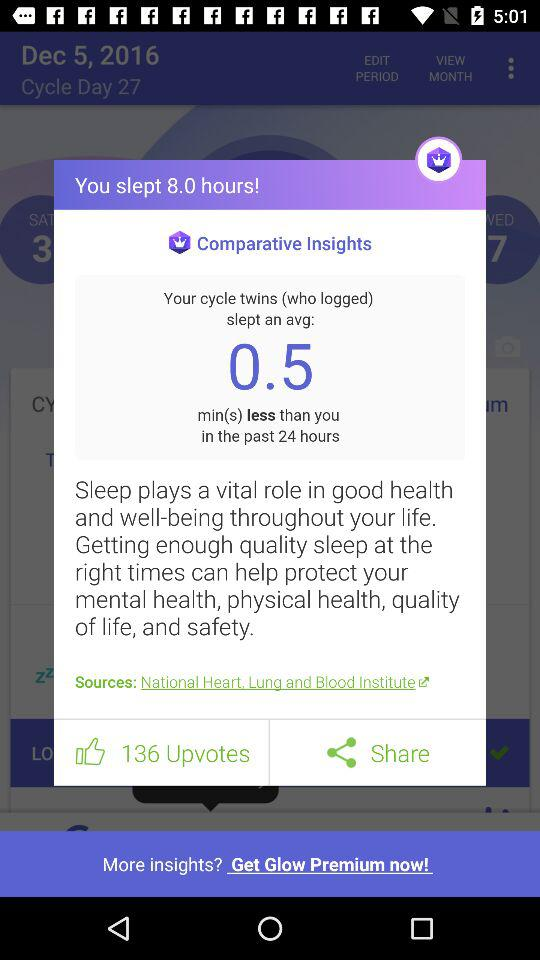How many minutes on average have my cycle twins slept less than me in the past 24 hours? Your cycle twins slept 0.5 minutes less on average than you in the past 24 hours. 